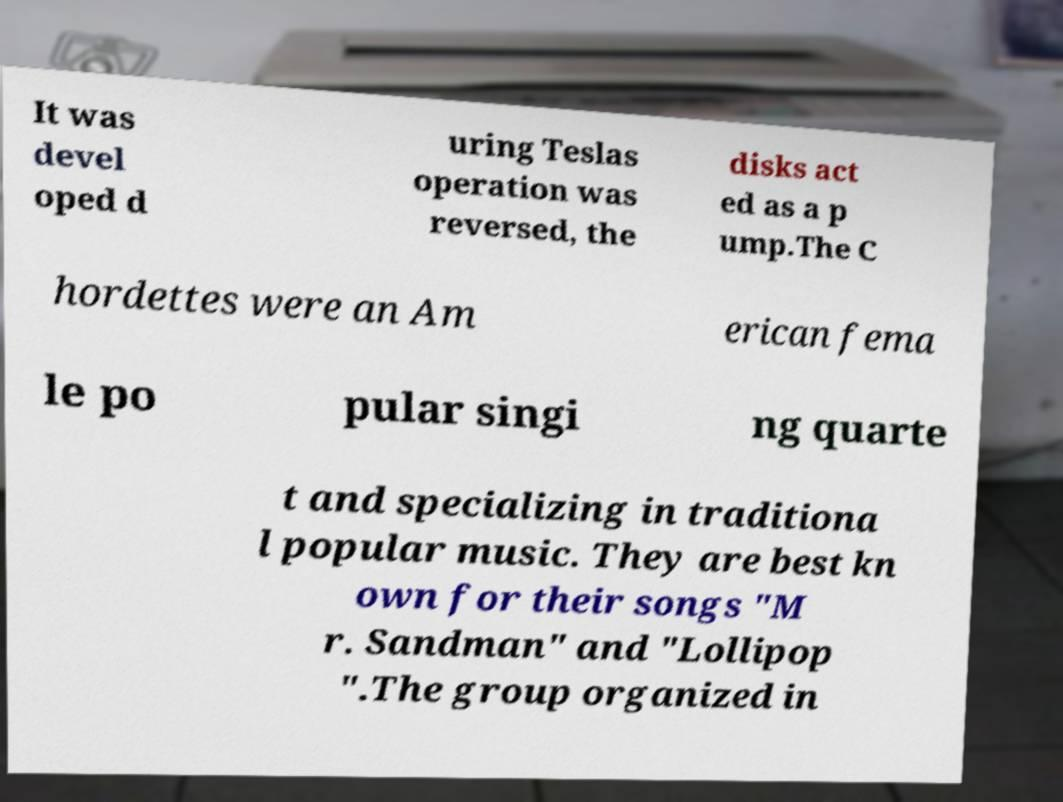There's text embedded in this image that I need extracted. Can you transcribe it verbatim? It was devel oped d uring Teslas operation was reversed, the disks act ed as a p ump.The C hordettes were an Am erican fema le po pular singi ng quarte t and specializing in traditiona l popular music. They are best kn own for their songs "M r. Sandman" and "Lollipop ".The group organized in 